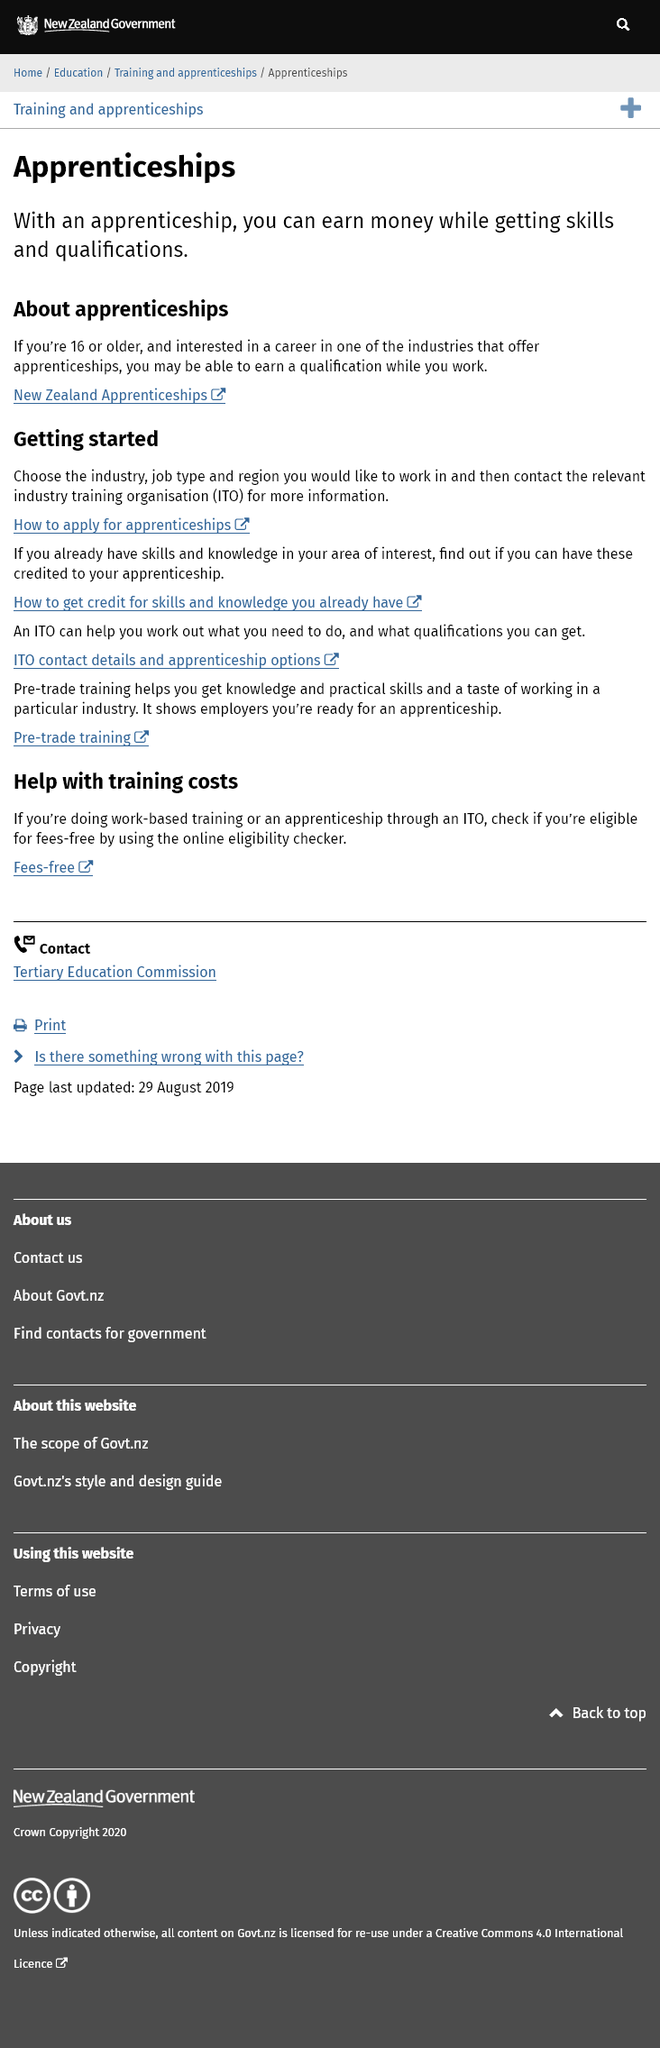Mention a couple of crucial points in this snapshot. It is legally required that individuals aged 16 or older can earn money while acquiring skills and qualifications through an apprenticeship. Yes, it is possible to earn money through an apprenticeship in New Zealand. Yes, it is possible to earn a qualification while working for apprenticeships in New Zealand. 